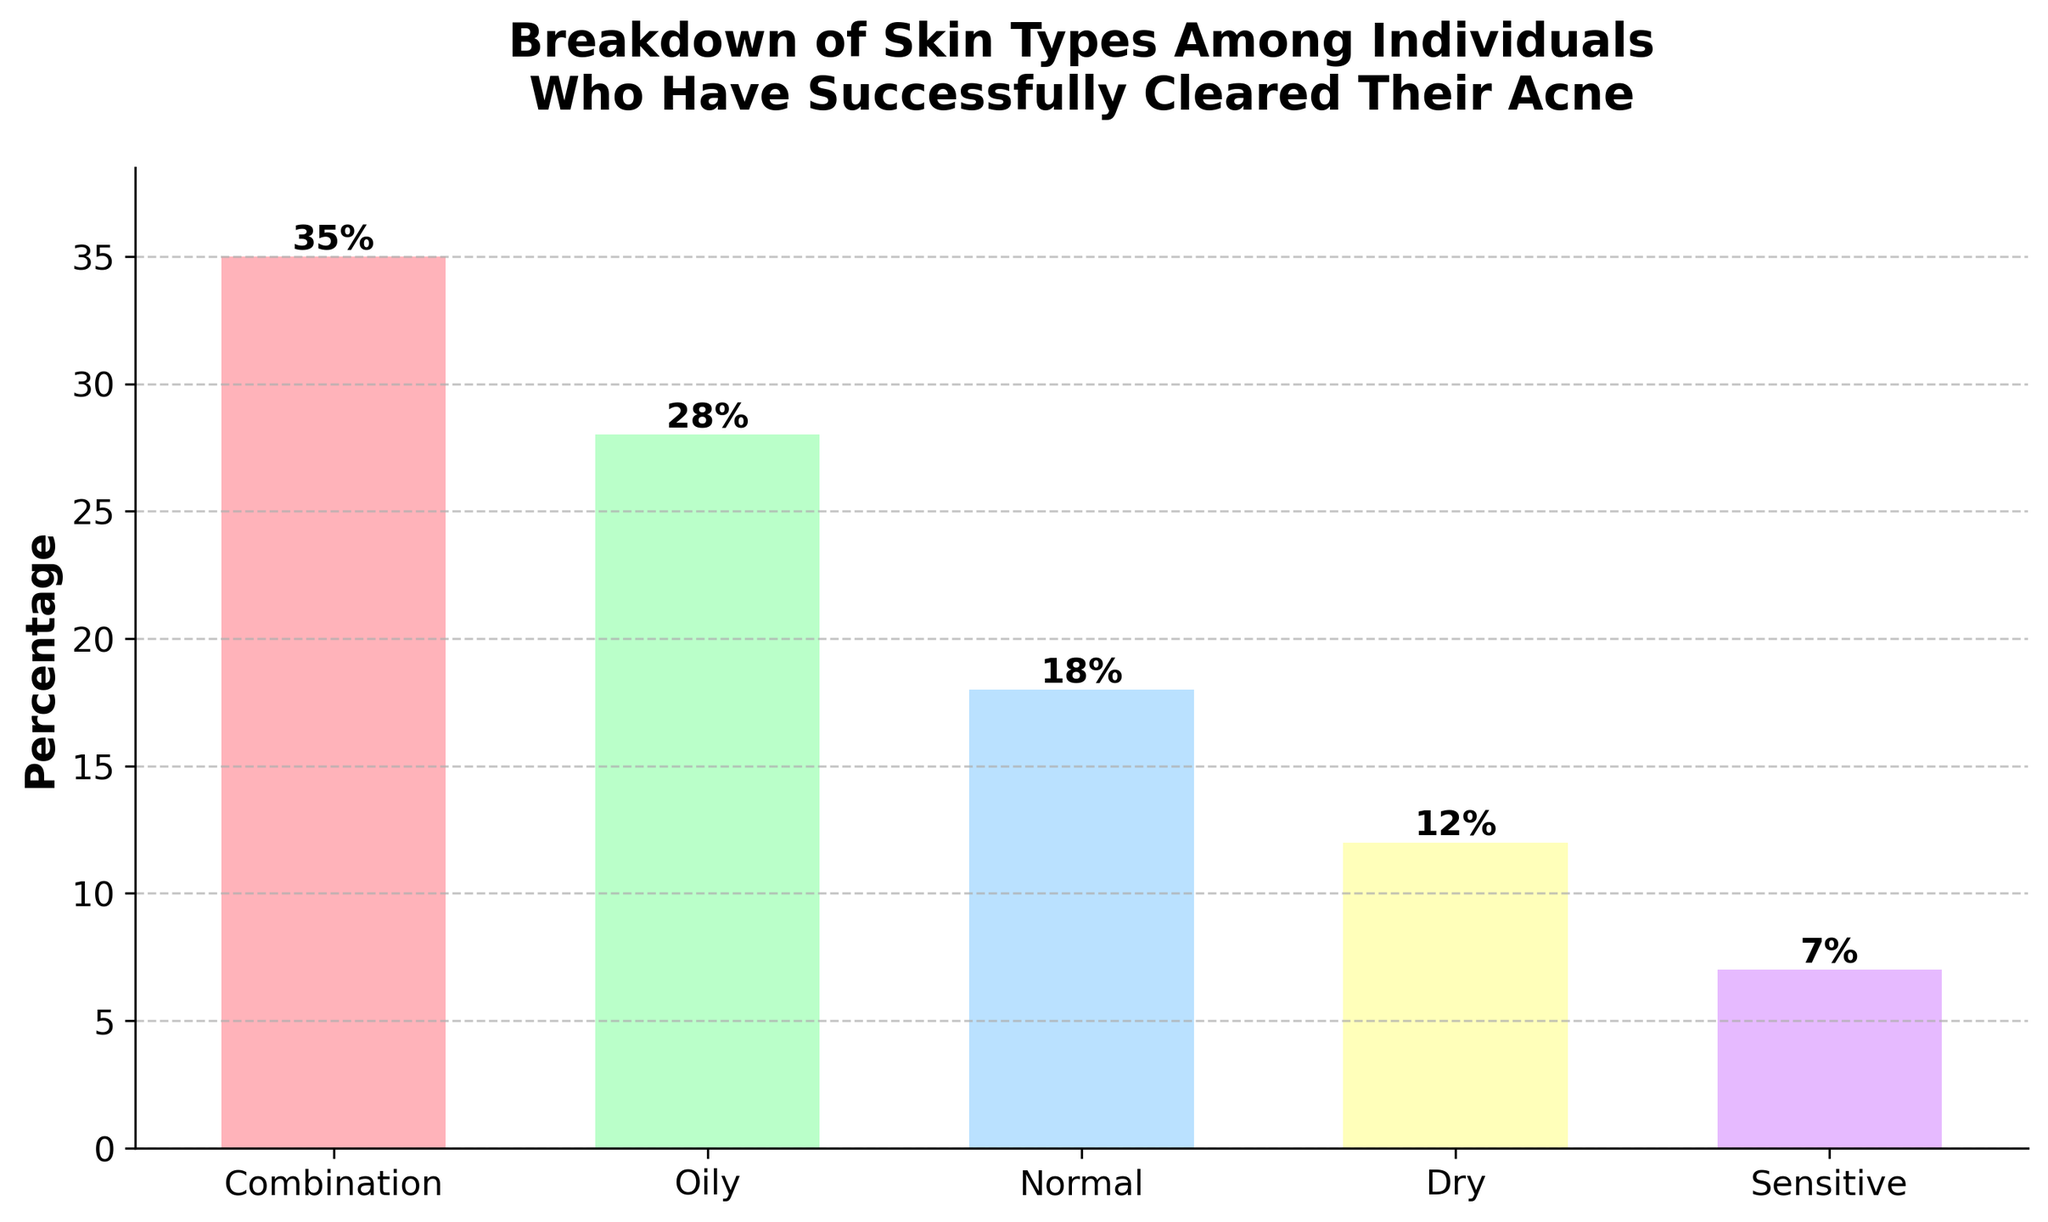What's the most common skin type among individuals who have successfully cleared their acne? The figure's highest bar represents the most common skin type. The tallest bar corresponds to the 'Combination' skin type.
Answer: Combination Which skin type has the least percentage among individuals who have successfully cleared their acne? The smallest bar represents the least common skin type. The shortest bar corresponds to the 'Sensitive' skin type.
Answer: Sensitive What is the total percentage of individuals with either 'Normal' or 'Dry' skin types? Add the percentages of 'Normal' and 'Dry' skin types. Normal = 18%, Dry = 12%, so the total is 18% + 12% = 30%.
Answer: 30% Compare the percentage of 'Oily' skin type to 'Sensitive' skin type. How much higher is 'Oily' compared to 'Sensitive'? Subtract the percentage of 'Sensitive' skin type from 'Oily' skin type. Oily = 28%, Sensitive = 7%, so the difference is 28% - 7% = 21%.
Answer: 21% What is the average percentage of the skin types listed in the figure? Sum all percentages and divide by the number of skin types. (35% + 28% + 18% + 12% + 7%) / 5 = 100% / 5 = 20%.
Answer: 20% How does the percentage of 'Combination' skin type compare to the average percentage of the skin types? The average percentage among all skin types is 20%. 'Combination' has 35%, which is higher than the average by 35% - 20% = 15%.
Answer: 15% higher What is the percentage difference between 'Dry' and 'Normal' skin types? Subtract the percentage of 'Dry' skin type from 'Normal' skin type. Dry = 12%, Normal = 18%, so the difference is 18% - 12% = 6%.
Answer: 6% Of the skin types shown, which one has a percentage closest to the average percentage? Calculate the difference between each skin type’s percentage and the average percentage (20%), then find the smallest difference. 'Oily' is closest to 20% with a percentage of 28%, which is an 8% difference.
Answer: Oily 